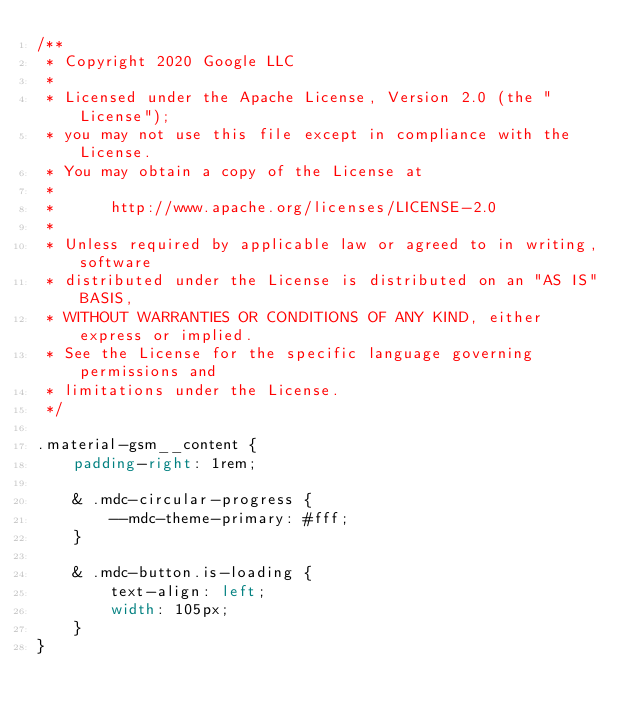<code> <loc_0><loc_0><loc_500><loc_500><_CSS_>/**
 * Copyright 2020 Google LLC
 *
 * Licensed under the Apache License, Version 2.0 (the "License");
 * you may not use this file except in compliance with the License.
 * You may obtain a copy of the License at
 *
 *      http://www.apache.org/licenses/LICENSE-2.0
 *
 * Unless required by applicable law or agreed to in writing, software
 * distributed under the License is distributed on an "AS IS" BASIS,
 * WITHOUT WARRANTIES OR CONDITIONS OF ANY KIND, either express or implied.
 * See the License for the specific language governing permissions and
 * limitations under the License.
 */

.material-gsm__content {
	padding-right: 1rem;

	& .mdc-circular-progress {
		--mdc-theme-primary: #fff;
	}

	& .mdc-button.is-loading {
		text-align: left;
		width: 105px;
	}
}
</code> 